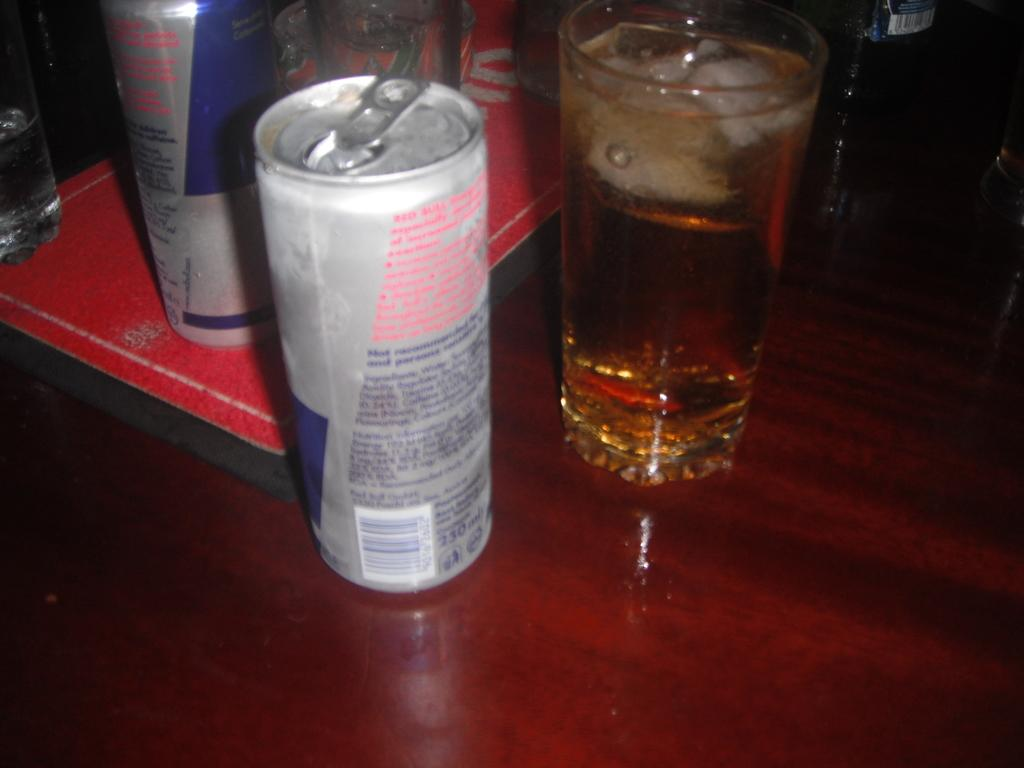How many tins are visible in the image? There are two tins in the image. What other objects can be seen in the image? There are glasses visible in the image. What is the color of the board on which the objects are placed? The objects are on a maroon color board. What is the color combination of the board on the table? There is a red and black color board in the image. Where is the red and black color board located? The red and black color board is on a table. What type of humor can be seen in the image? There is no humor present in the image; it features tins, glasses, and a colorful board. Can you tell me how many marbles are on the table in the image? There are no marbles present in the image; it features tins, glasses, and a colorful board. 